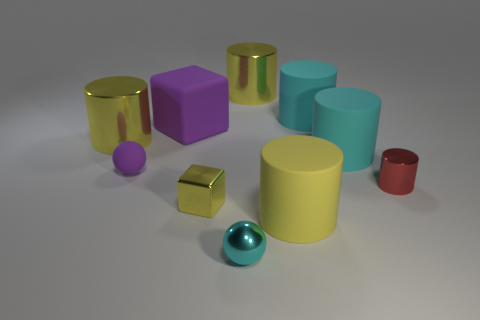There is a purple ball; does it have the same size as the yellow cylinder that is in front of the purple sphere?
Make the answer very short. No. Are there the same number of big yellow objects in front of the tiny cylinder and big yellow things that are on the left side of the big yellow rubber cylinder?
Provide a short and direct response. No. What shape is the rubber thing that is the same color as the tiny shiny block?
Ensure brevity in your answer.  Cylinder. What material is the cylinder that is to the left of the large purple block?
Offer a terse response. Metal. Does the yellow matte object have the same size as the purple block?
Offer a very short reply. Yes. Is the number of things that are left of the red shiny thing greater than the number of big metal things?
Keep it short and to the point. Yes. The yellow block that is made of the same material as the tiny cyan sphere is what size?
Ensure brevity in your answer.  Small. Are there any cyan matte objects in front of the tiny yellow metallic object?
Your answer should be very brief. No. Is the shape of the small red object the same as the yellow matte object?
Ensure brevity in your answer.  Yes. What size is the sphere behind the small object to the right of the matte object in front of the small cylinder?
Offer a terse response. Small. 